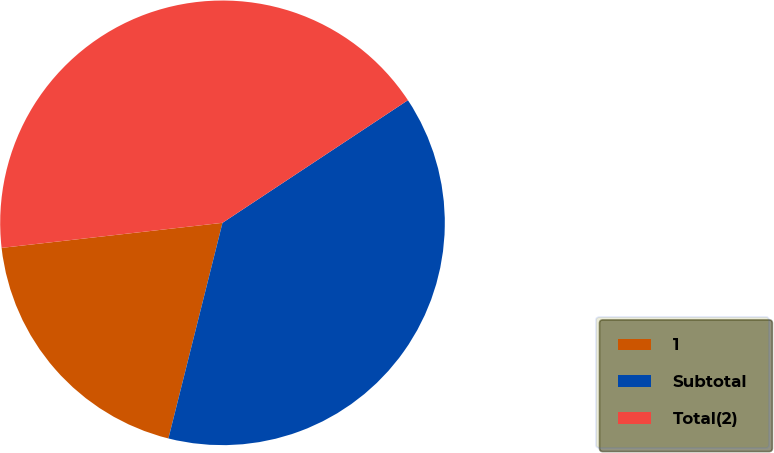<chart> <loc_0><loc_0><loc_500><loc_500><pie_chart><fcel>1<fcel>Subtotal<fcel>Total(2)<nl><fcel>19.29%<fcel>38.21%<fcel>42.5%<nl></chart> 